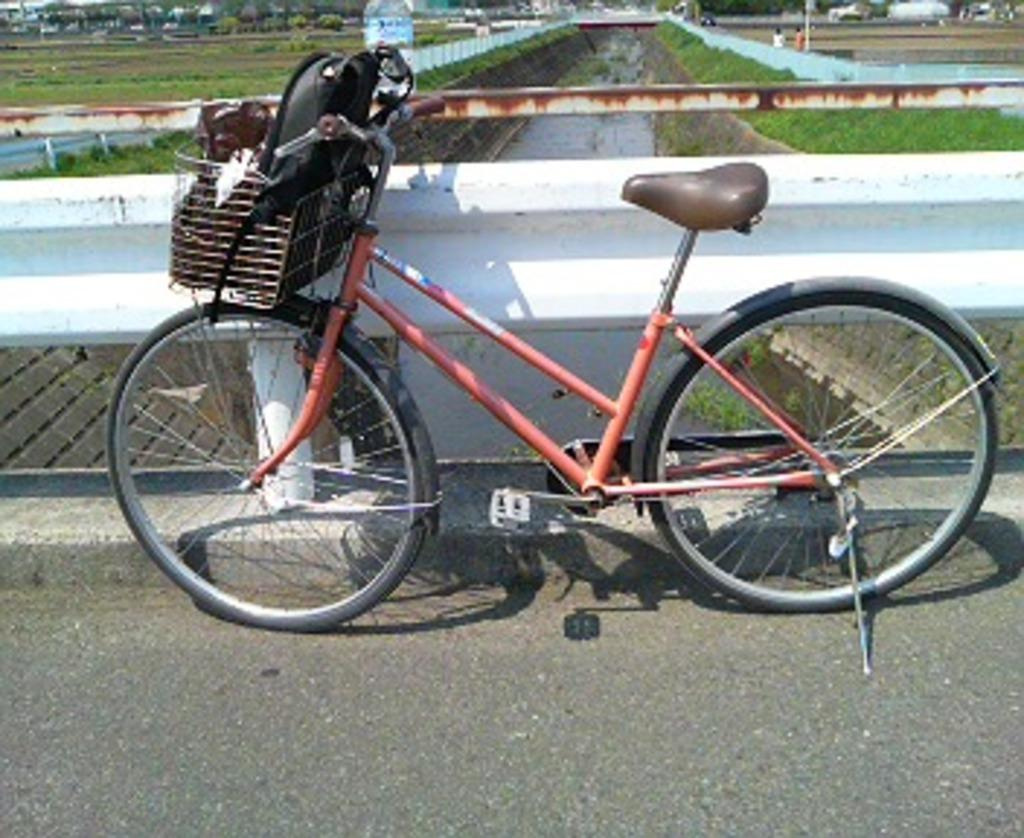What type of vehicle is in the image? There is a cycle with a basket in the image. What is inside the basket of the cycle? There is a bag inside the basket. What is located near the cycle? There is a wall near the cycle. What can be seen in the background of the image? Water and plants are visible in the background. What type of desk is visible in the image? There is no desk present in the image. What effect does the force of the water have on the plants in the background? There is no information about the force of the water or its effect on the plants in the image. 